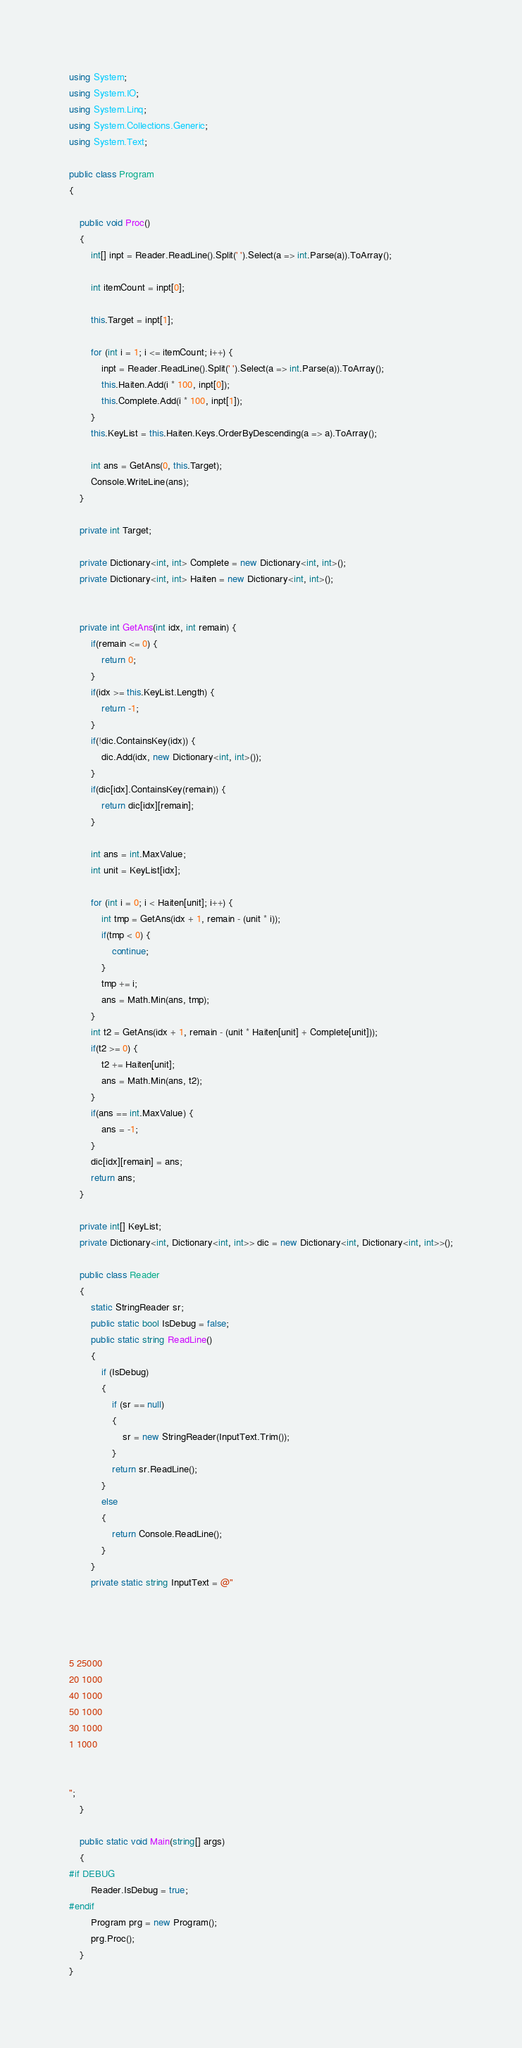<code> <loc_0><loc_0><loc_500><loc_500><_C#_>using System;
using System.IO;
using System.Linq;
using System.Collections.Generic;
using System.Text;

public class Program
{

    public void Proc()
    {
        int[] inpt = Reader.ReadLine().Split(' ').Select(a => int.Parse(a)).ToArray();

        int itemCount = inpt[0];

        this.Target = inpt[1];

        for (int i = 1; i <= itemCount; i++) {
            inpt = Reader.ReadLine().Split(' ').Select(a => int.Parse(a)).ToArray();
            this.Haiten.Add(i * 100, inpt[0]);
            this.Complete.Add(i * 100, inpt[1]);
        }
        this.KeyList = this.Haiten.Keys.OrderByDescending(a => a).ToArray();

        int ans = GetAns(0, this.Target);
        Console.WriteLine(ans);
    }

    private int Target;

    private Dictionary<int, int> Complete = new Dictionary<int, int>();
    private Dictionary<int, int> Haiten = new Dictionary<int, int>();


    private int GetAns(int idx, int remain) {
        if(remain <= 0) {
            return 0;
        }
        if(idx >= this.KeyList.Length) {
            return -1;
        }
        if(!dic.ContainsKey(idx)) {
            dic.Add(idx, new Dictionary<int, int>());
        }
        if(dic[idx].ContainsKey(remain)) {
            return dic[idx][remain];
        }

        int ans = int.MaxValue;
        int unit = KeyList[idx];

        for (int i = 0; i < Haiten[unit]; i++) {
            int tmp = GetAns(idx + 1, remain - (unit * i));
            if(tmp < 0) {
                continue;
            }
            tmp += i;
            ans = Math.Min(ans, tmp);
        }
        int t2 = GetAns(idx + 1, remain - (unit * Haiten[unit] + Complete[unit]));
        if(t2 >= 0) {
            t2 += Haiten[unit];
            ans = Math.Min(ans, t2);
        }
        if(ans == int.MaxValue) {
            ans = -1;
        }
        dic[idx][remain] = ans;
        return ans;
    }

    private int[] KeyList;
    private Dictionary<int, Dictionary<int, int>> dic = new Dictionary<int, Dictionary<int, int>>();

    public class Reader
    {
        static StringReader sr;
        public static bool IsDebug = false;
        public static string ReadLine()
        {
            if (IsDebug)
            {
                if (sr == null)
                {
                    sr = new StringReader(InputText.Trim());
                }
                return sr.ReadLine();
            }
            else
            {
                return Console.ReadLine();
            }
        }
        private static string InputText = @"




5 25000
20 1000
40 1000
50 1000
30 1000
1 1000


";
    }

    public static void Main(string[] args)
    {
#if DEBUG
        Reader.IsDebug = true;
#endif
        Program prg = new Program();
        prg.Proc();
    }
}</code> 